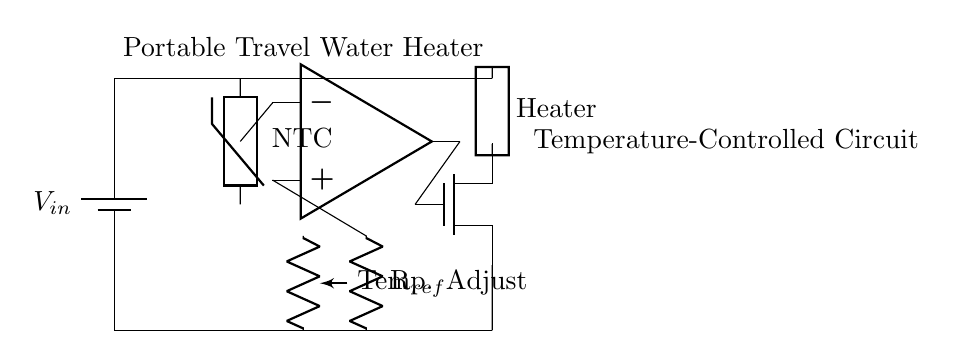What is the main component that controls the heating? The main component that controls the heating in this circuit is the power MOSFET. The MOSFET receives a signal from the comparator, which determines when to turn on and off, thus regulating the power to the heating element based on the temperature measurement.
Answer: MOSFET What type of temperature sensor is used in this circuit? The circuit uses a thermistor, specifically a negative temperature coefficient (NTC) thermistor. This type of sensor decreases its resistance as the temperature increases, allowing it to effectively monitor temperature changes.
Answer: NTC thermistor What is the function of the comparator in this circuit? The comparator's function is to compare the output of the thermistor with a reference voltage. Based on this comparison, it generates a control signal that signals the MOSFET to either allow current to flow through the heating element or cut it off, thereby maintaining the desired temperature.
Answer: Control signal How does the thermal regulation occur in this circuit? Thermal regulation occurs through a feedback loop: the thermistor measures the water temperature, the comparator compares this temperature to a set reference value, and based on the result, the MOSFET controls the power to the heating element. If the water reaches the desired temperature, the heating element is turned off.
Answer: Feedback loop What component serves as the temperature adjustment feature in the circuit? The temperature adjustment feature is represented by a variable resistor connected in the circuit. This component allows the user to set the desired reference temperature that the comparator will use to regulate the heating.
Answer: Variable resistor 